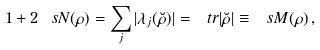<formula> <loc_0><loc_0><loc_500><loc_500>1 + 2 \ s N ( \rho ) = \sum _ { j } | \lambda _ { j } ( \breve { \rho } ) | = \ t r | \breve { \rho } | \equiv \ s M ( \rho ) \, ,</formula> 